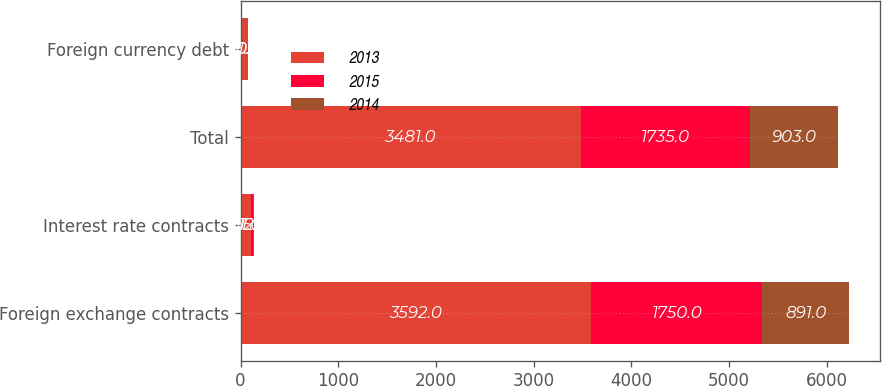Convert chart. <chart><loc_0><loc_0><loc_500><loc_500><stacked_bar_chart><ecel><fcel>Foreign exchange contracts<fcel>Interest rate contracts<fcel>Total<fcel>Foreign currency debt<nl><fcel>2013<fcel>3592<fcel>111<fcel>3481<fcel>71<nl><fcel>2015<fcel>1750<fcel>15<fcel>1735<fcel>0<nl><fcel>2014<fcel>891<fcel>12<fcel>903<fcel>0<nl></chart> 